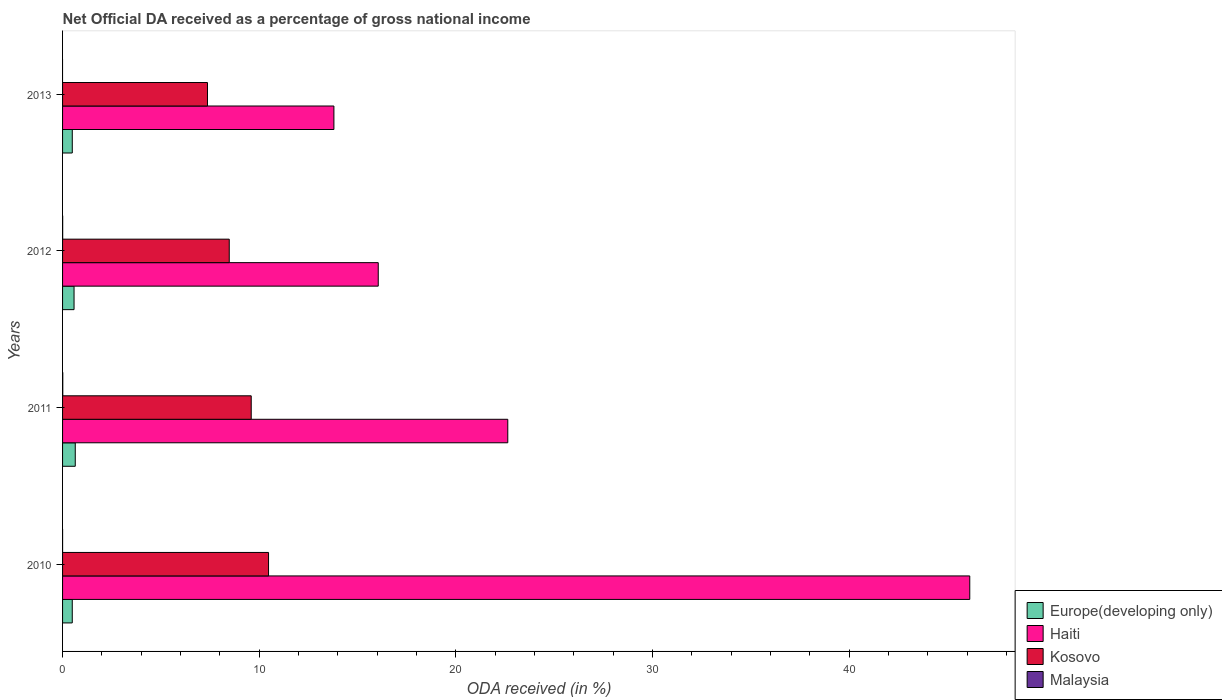Are the number of bars per tick equal to the number of legend labels?
Make the answer very short. No. How many bars are there on the 3rd tick from the top?
Ensure brevity in your answer.  4. How many bars are there on the 2nd tick from the bottom?
Your answer should be very brief. 4. In how many cases, is the number of bars for a given year not equal to the number of legend labels?
Offer a very short reply. 1. What is the net official DA received in Malaysia in 2012?
Offer a terse response. 0.01. Across all years, what is the maximum net official DA received in Malaysia?
Keep it short and to the point. 0.01. Across all years, what is the minimum net official DA received in Haiti?
Ensure brevity in your answer.  13.8. What is the total net official DA received in Malaysia in the graph?
Provide a short and direct response. 0.02. What is the difference between the net official DA received in Kosovo in 2010 and that in 2011?
Ensure brevity in your answer.  0.88. What is the difference between the net official DA received in Kosovo in 2011 and the net official DA received in Malaysia in 2012?
Keep it short and to the point. 9.59. What is the average net official DA received in Europe(developing only) per year?
Make the answer very short. 0.55. In the year 2012, what is the difference between the net official DA received in Kosovo and net official DA received in Europe(developing only)?
Provide a succinct answer. 7.89. What is the ratio of the net official DA received in Europe(developing only) in 2010 to that in 2012?
Provide a succinct answer. 0.84. Is the net official DA received in Haiti in 2011 less than that in 2012?
Your answer should be compact. No. What is the difference between the highest and the second highest net official DA received in Haiti?
Your answer should be very brief. 23.49. What is the difference between the highest and the lowest net official DA received in Kosovo?
Your response must be concise. 3.1. In how many years, is the net official DA received in Kosovo greater than the average net official DA received in Kosovo taken over all years?
Offer a terse response. 2. Is the sum of the net official DA received in Haiti in 2010 and 2011 greater than the maximum net official DA received in Malaysia across all years?
Provide a succinct answer. Yes. Is it the case that in every year, the sum of the net official DA received in Kosovo and net official DA received in Europe(developing only) is greater than the sum of net official DA received in Malaysia and net official DA received in Haiti?
Offer a terse response. Yes. Is it the case that in every year, the sum of the net official DA received in Haiti and net official DA received in Malaysia is greater than the net official DA received in Europe(developing only)?
Provide a short and direct response. Yes. Are all the bars in the graph horizontal?
Provide a succinct answer. Yes. What is the difference between two consecutive major ticks on the X-axis?
Give a very brief answer. 10. Does the graph contain grids?
Your answer should be very brief. No. How many legend labels are there?
Keep it short and to the point. 4. What is the title of the graph?
Offer a very short reply. Net Official DA received as a percentage of gross national income. What is the label or title of the X-axis?
Keep it short and to the point. ODA received (in %). What is the label or title of the Y-axis?
Make the answer very short. Years. What is the ODA received (in %) in Europe(developing only) in 2010?
Ensure brevity in your answer.  0.49. What is the ODA received (in %) of Haiti in 2010?
Ensure brevity in your answer.  46.13. What is the ODA received (in %) of Kosovo in 2010?
Your response must be concise. 10.47. What is the ODA received (in %) in Malaysia in 2010?
Keep it short and to the point. 0. What is the ODA received (in %) in Europe(developing only) in 2011?
Provide a succinct answer. 0.65. What is the ODA received (in %) in Haiti in 2011?
Keep it short and to the point. 22.64. What is the ODA received (in %) of Kosovo in 2011?
Provide a short and direct response. 9.59. What is the ODA received (in %) in Malaysia in 2011?
Your response must be concise. 0.01. What is the ODA received (in %) in Europe(developing only) in 2012?
Offer a terse response. 0.58. What is the ODA received (in %) in Haiti in 2012?
Offer a very short reply. 16.05. What is the ODA received (in %) of Kosovo in 2012?
Offer a terse response. 8.47. What is the ODA received (in %) in Malaysia in 2012?
Offer a very short reply. 0.01. What is the ODA received (in %) in Europe(developing only) in 2013?
Offer a very short reply. 0.49. What is the ODA received (in %) in Haiti in 2013?
Make the answer very short. 13.8. What is the ODA received (in %) in Kosovo in 2013?
Offer a terse response. 7.37. What is the ODA received (in %) in Malaysia in 2013?
Your response must be concise. 0. Across all years, what is the maximum ODA received (in %) in Europe(developing only)?
Provide a short and direct response. 0.65. Across all years, what is the maximum ODA received (in %) of Haiti?
Your answer should be very brief. 46.13. Across all years, what is the maximum ODA received (in %) of Kosovo?
Offer a terse response. 10.47. Across all years, what is the maximum ODA received (in %) of Malaysia?
Provide a short and direct response. 0.01. Across all years, what is the minimum ODA received (in %) in Europe(developing only)?
Ensure brevity in your answer.  0.49. Across all years, what is the minimum ODA received (in %) of Haiti?
Provide a short and direct response. 13.8. Across all years, what is the minimum ODA received (in %) in Kosovo?
Offer a terse response. 7.37. Across all years, what is the minimum ODA received (in %) of Malaysia?
Your answer should be very brief. 0. What is the total ODA received (in %) of Europe(developing only) in the graph?
Provide a succinct answer. 2.22. What is the total ODA received (in %) in Haiti in the graph?
Your answer should be very brief. 98.61. What is the total ODA received (in %) in Kosovo in the graph?
Your response must be concise. 35.91. What is the total ODA received (in %) of Malaysia in the graph?
Give a very brief answer. 0.02. What is the difference between the ODA received (in %) of Europe(developing only) in 2010 and that in 2011?
Give a very brief answer. -0.15. What is the difference between the ODA received (in %) of Haiti in 2010 and that in 2011?
Give a very brief answer. 23.49. What is the difference between the ODA received (in %) in Kosovo in 2010 and that in 2011?
Your answer should be compact. 0.88. What is the difference between the ODA received (in %) of Malaysia in 2010 and that in 2011?
Keep it short and to the point. -0.01. What is the difference between the ODA received (in %) of Europe(developing only) in 2010 and that in 2012?
Provide a succinct answer. -0.09. What is the difference between the ODA received (in %) in Haiti in 2010 and that in 2012?
Make the answer very short. 30.07. What is the difference between the ODA received (in %) of Kosovo in 2010 and that in 2012?
Your answer should be compact. 2. What is the difference between the ODA received (in %) in Malaysia in 2010 and that in 2012?
Your answer should be very brief. -0. What is the difference between the ODA received (in %) in Europe(developing only) in 2010 and that in 2013?
Your answer should be very brief. -0. What is the difference between the ODA received (in %) in Haiti in 2010 and that in 2013?
Give a very brief answer. 32.33. What is the difference between the ODA received (in %) of Kosovo in 2010 and that in 2013?
Provide a short and direct response. 3.1. What is the difference between the ODA received (in %) in Europe(developing only) in 2011 and that in 2012?
Offer a very short reply. 0.06. What is the difference between the ODA received (in %) in Haiti in 2011 and that in 2012?
Offer a very short reply. 6.59. What is the difference between the ODA received (in %) of Kosovo in 2011 and that in 2012?
Give a very brief answer. 1.12. What is the difference between the ODA received (in %) of Malaysia in 2011 and that in 2012?
Offer a very short reply. 0.01. What is the difference between the ODA received (in %) in Europe(developing only) in 2011 and that in 2013?
Keep it short and to the point. 0.15. What is the difference between the ODA received (in %) of Haiti in 2011 and that in 2013?
Make the answer very short. 8.84. What is the difference between the ODA received (in %) in Kosovo in 2011 and that in 2013?
Your answer should be very brief. 2.22. What is the difference between the ODA received (in %) in Europe(developing only) in 2012 and that in 2013?
Offer a very short reply. 0.09. What is the difference between the ODA received (in %) in Haiti in 2012 and that in 2013?
Offer a terse response. 2.25. What is the difference between the ODA received (in %) of Kosovo in 2012 and that in 2013?
Make the answer very short. 1.11. What is the difference between the ODA received (in %) of Europe(developing only) in 2010 and the ODA received (in %) of Haiti in 2011?
Make the answer very short. -22.14. What is the difference between the ODA received (in %) in Europe(developing only) in 2010 and the ODA received (in %) in Kosovo in 2011?
Keep it short and to the point. -9.1. What is the difference between the ODA received (in %) of Europe(developing only) in 2010 and the ODA received (in %) of Malaysia in 2011?
Your answer should be compact. 0.48. What is the difference between the ODA received (in %) of Haiti in 2010 and the ODA received (in %) of Kosovo in 2011?
Your answer should be compact. 36.53. What is the difference between the ODA received (in %) in Haiti in 2010 and the ODA received (in %) in Malaysia in 2011?
Provide a succinct answer. 46.11. What is the difference between the ODA received (in %) in Kosovo in 2010 and the ODA received (in %) in Malaysia in 2011?
Ensure brevity in your answer.  10.46. What is the difference between the ODA received (in %) of Europe(developing only) in 2010 and the ODA received (in %) of Haiti in 2012?
Offer a terse response. -15.56. What is the difference between the ODA received (in %) of Europe(developing only) in 2010 and the ODA received (in %) of Kosovo in 2012?
Give a very brief answer. -7.98. What is the difference between the ODA received (in %) of Europe(developing only) in 2010 and the ODA received (in %) of Malaysia in 2012?
Offer a terse response. 0.49. What is the difference between the ODA received (in %) in Haiti in 2010 and the ODA received (in %) in Kosovo in 2012?
Provide a succinct answer. 37.65. What is the difference between the ODA received (in %) in Haiti in 2010 and the ODA received (in %) in Malaysia in 2012?
Give a very brief answer. 46.12. What is the difference between the ODA received (in %) in Kosovo in 2010 and the ODA received (in %) in Malaysia in 2012?
Keep it short and to the point. 10.47. What is the difference between the ODA received (in %) in Europe(developing only) in 2010 and the ODA received (in %) in Haiti in 2013?
Provide a succinct answer. -13.3. What is the difference between the ODA received (in %) of Europe(developing only) in 2010 and the ODA received (in %) of Kosovo in 2013?
Keep it short and to the point. -6.88. What is the difference between the ODA received (in %) of Haiti in 2010 and the ODA received (in %) of Kosovo in 2013?
Provide a succinct answer. 38.76. What is the difference between the ODA received (in %) in Europe(developing only) in 2011 and the ODA received (in %) in Haiti in 2012?
Provide a short and direct response. -15.41. What is the difference between the ODA received (in %) in Europe(developing only) in 2011 and the ODA received (in %) in Kosovo in 2012?
Your answer should be very brief. -7.83. What is the difference between the ODA received (in %) of Europe(developing only) in 2011 and the ODA received (in %) of Malaysia in 2012?
Offer a very short reply. 0.64. What is the difference between the ODA received (in %) in Haiti in 2011 and the ODA received (in %) in Kosovo in 2012?
Offer a very short reply. 14.16. What is the difference between the ODA received (in %) in Haiti in 2011 and the ODA received (in %) in Malaysia in 2012?
Offer a terse response. 22.63. What is the difference between the ODA received (in %) in Kosovo in 2011 and the ODA received (in %) in Malaysia in 2012?
Keep it short and to the point. 9.59. What is the difference between the ODA received (in %) in Europe(developing only) in 2011 and the ODA received (in %) in Haiti in 2013?
Ensure brevity in your answer.  -13.15. What is the difference between the ODA received (in %) in Europe(developing only) in 2011 and the ODA received (in %) in Kosovo in 2013?
Make the answer very short. -6.72. What is the difference between the ODA received (in %) in Haiti in 2011 and the ODA received (in %) in Kosovo in 2013?
Your response must be concise. 15.27. What is the difference between the ODA received (in %) in Europe(developing only) in 2012 and the ODA received (in %) in Haiti in 2013?
Offer a very short reply. -13.21. What is the difference between the ODA received (in %) in Europe(developing only) in 2012 and the ODA received (in %) in Kosovo in 2013?
Your answer should be very brief. -6.78. What is the difference between the ODA received (in %) of Haiti in 2012 and the ODA received (in %) of Kosovo in 2013?
Keep it short and to the point. 8.68. What is the average ODA received (in %) in Europe(developing only) per year?
Your answer should be very brief. 0.55. What is the average ODA received (in %) in Haiti per year?
Keep it short and to the point. 24.65. What is the average ODA received (in %) of Kosovo per year?
Your answer should be very brief. 8.98. What is the average ODA received (in %) of Malaysia per year?
Your answer should be very brief. 0. In the year 2010, what is the difference between the ODA received (in %) of Europe(developing only) and ODA received (in %) of Haiti?
Offer a terse response. -45.63. In the year 2010, what is the difference between the ODA received (in %) in Europe(developing only) and ODA received (in %) in Kosovo?
Your response must be concise. -9.98. In the year 2010, what is the difference between the ODA received (in %) of Europe(developing only) and ODA received (in %) of Malaysia?
Keep it short and to the point. 0.49. In the year 2010, what is the difference between the ODA received (in %) of Haiti and ODA received (in %) of Kosovo?
Give a very brief answer. 35.65. In the year 2010, what is the difference between the ODA received (in %) in Haiti and ODA received (in %) in Malaysia?
Make the answer very short. 46.12. In the year 2010, what is the difference between the ODA received (in %) of Kosovo and ODA received (in %) of Malaysia?
Your response must be concise. 10.47. In the year 2011, what is the difference between the ODA received (in %) in Europe(developing only) and ODA received (in %) in Haiti?
Offer a terse response. -21.99. In the year 2011, what is the difference between the ODA received (in %) in Europe(developing only) and ODA received (in %) in Kosovo?
Offer a terse response. -8.95. In the year 2011, what is the difference between the ODA received (in %) in Europe(developing only) and ODA received (in %) in Malaysia?
Give a very brief answer. 0.63. In the year 2011, what is the difference between the ODA received (in %) in Haiti and ODA received (in %) in Kosovo?
Make the answer very short. 13.04. In the year 2011, what is the difference between the ODA received (in %) of Haiti and ODA received (in %) of Malaysia?
Give a very brief answer. 22.63. In the year 2011, what is the difference between the ODA received (in %) in Kosovo and ODA received (in %) in Malaysia?
Your answer should be very brief. 9.58. In the year 2012, what is the difference between the ODA received (in %) in Europe(developing only) and ODA received (in %) in Haiti?
Give a very brief answer. -15.47. In the year 2012, what is the difference between the ODA received (in %) in Europe(developing only) and ODA received (in %) in Kosovo?
Ensure brevity in your answer.  -7.89. In the year 2012, what is the difference between the ODA received (in %) of Europe(developing only) and ODA received (in %) of Malaysia?
Your response must be concise. 0.58. In the year 2012, what is the difference between the ODA received (in %) in Haiti and ODA received (in %) in Kosovo?
Provide a short and direct response. 7.58. In the year 2012, what is the difference between the ODA received (in %) in Haiti and ODA received (in %) in Malaysia?
Offer a very short reply. 16.05. In the year 2012, what is the difference between the ODA received (in %) in Kosovo and ODA received (in %) in Malaysia?
Your answer should be compact. 8.47. In the year 2013, what is the difference between the ODA received (in %) in Europe(developing only) and ODA received (in %) in Haiti?
Your answer should be very brief. -13.3. In the year 2013, what is the difference between the ODA received (in %) of Europe(developing only) and ODA received (in %) of Kosovo?
Make the answer very short. -6.87. In the year 2013, what is the difference between the ODA received (in %) of Haiti and ODA received (in %) of Kosovo?
Ensure brevity in your answer.  6.43. What is the ratio of the ODA received (in %) in Europe(developing only) in 2010 to that in 2011?
Offer a terse response. 0.76. What is the ratio of the ODA received (in %) in Haiti in 2010 to that in 2011?
Provide a short and direct response. 2.04. What is the ratio of the ODA received (in %) in Kosovo in 2010 to that in 2011?
Ensure brevity in your answer.  1.09. What is the ratio of the ODA received (in %) in Malaysia in 2010 to that in 2011?
Give a very brief answer. 0.08. What is the ratio of the ODA received (in %) of Europe(developing only) in 2010 to that in 2012?
Give a very brief answer. 0.84. What is the ratio of the ODA received (in %) in Haiti in 2010 to that in 2012?
Make the answer very short. 2.87. What is the ratio of the ODA received (in %) in Kosovo in 2010 to that in 2012?
Your answer should be compact. 1.24. What is the ratio of the ODA received (in %) of Malaysia in 2010 to that in 2012?
Give a very brief answer. 0.16. What is the ratio of the ODA received (in %) of Europe(developing only) in 2010 to that in 2013?
Keep it short and to the point. 1. What is the ratio of the ODA received (in %) of Haiti in 2010 to that in 2013?
Provide a succinct answer. 3.34. What is the ratio of the ODA received (in %) of Kosovo in 2010 to that in 2013?
Offer a very short reply. 1.42. What is the ratio of the ODA received (in %) in Europe(developing only) in 2011 to that in 2012?
Offer a very short reply. 1.11. What is the ratio of the ODA received (in %) of Haiti in 2011 to that in 2012?
Ensure brevity in your answer.  1.41. What is the ratio of the ODA received (in %) of Kosovo in 2011 to that in 2012?
Keep it short and to the point. 1.13. What is the ratio of the ODA received (in %) in Malaysia in 2011 to that in 2012?
Give a very brief answer. 2.17. What is the ratio of the ODA received (in %) in Europe(developing only) in 2011 to that in 2013?
Give a very brief answer. 1.31. What is the ratio of the ODA received (in %) of Haiti in 2011 to that in 2013?
Offer a very short reply. 1.64. What is the ratio of the ODA received (in %) in Kosovo in 2011 to that in 2013?
Provide a short and direct response. 1.3. What is the ratio of the ODA received (in %) in Europe(developing only) in 2012 to that in 2013?
Offer a terse response. 1.18. What is the ratio of the ODA received (in %) in Haiti in 2012 to that in 2013?
Offer a very short reply. 1.16. What is the ratio of the ODA received (in %) in Kosovo in 2012 to that in 2013?
Provide a short and direct response. 1.15. What is the difference between the highest and the second highest ODA received (in %) of Europe(developing only)?
Provide a short and direct response. 0.06. What is the difference between the highest and the second highest ODA received (in %) in Haiti?
Your answer should be very brief. 23.49. What is the difference between the highest and the second highest ODA received (in %) of Kosovo?
Provide a succinct answer. 0.88. What is the difference between the highest and the second highest ODA received (in %) in Malaysia?
Ensure brevity in your answer.  0.01. What is the difference between the highest and the lowest ODA received (in %) of Europe(developing only)?
Your response must be concise. 0.15. What is the difference between the highest and the lowest ODA received (in %) in Haiti?
Offer a terse response. 32.33. What is the difference between the highest and the lowest ODA received (in %) of Kosovo?
Keep it short and to the point. 3.1. What is the difference between the highest and the lowest ODA received (in %) of Malaysia?
Provide a short and direct response. 0.01. 